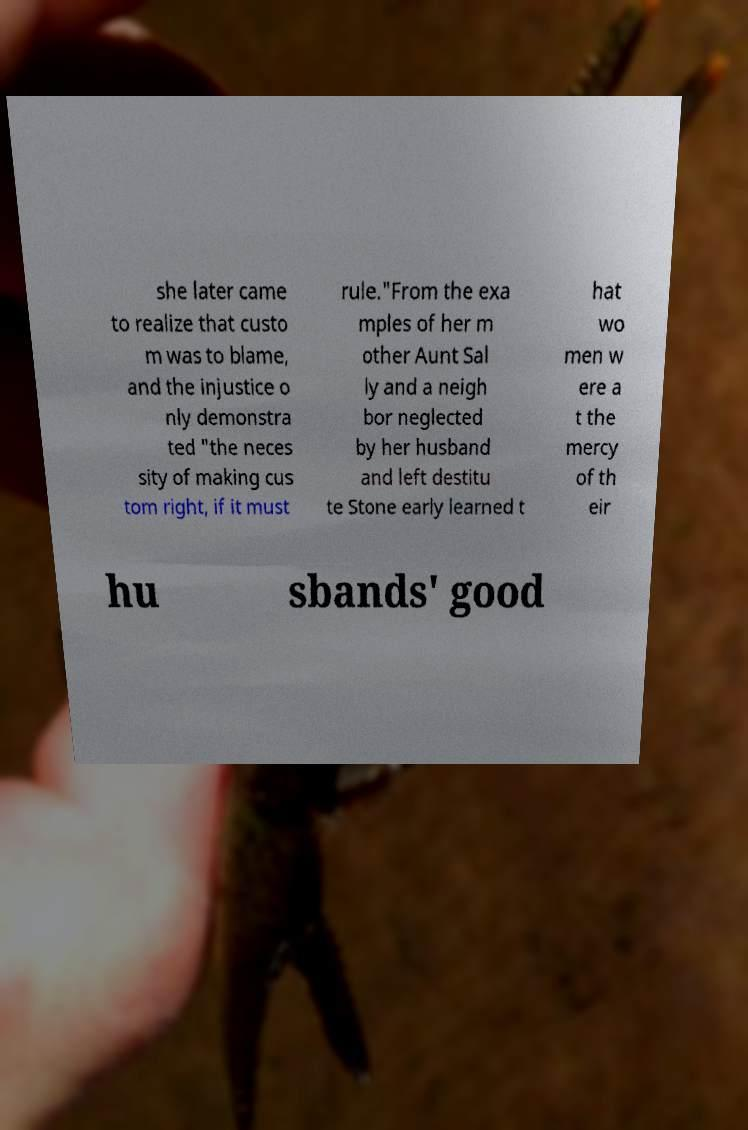There's text embedded in this image that I need extracted. Can you transcribe it verbatim? she later came to realize that custo m was to blame, and the injustice o nly demonstra ted "the neces sity of making cus tom right, if it must rule."From the exa mples of her m other Aunt Sal ly and a neigh bor neglected by her husband and left destitu te Stone early learned t hat wo men w ere a t the mercy of th eir hu sbands' good 